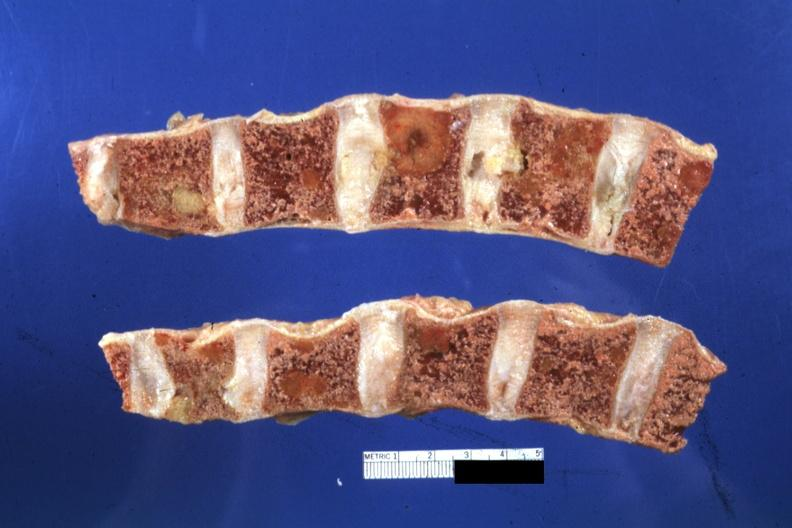do fixed lesions show well?
Answer the question using a single word or phrase. Yes 